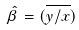Convert formula to latex. <formula><loc_0><loc_0><loc_500><loc_500>\hat { \beta } = ( \overline { y / x } )</formula> 